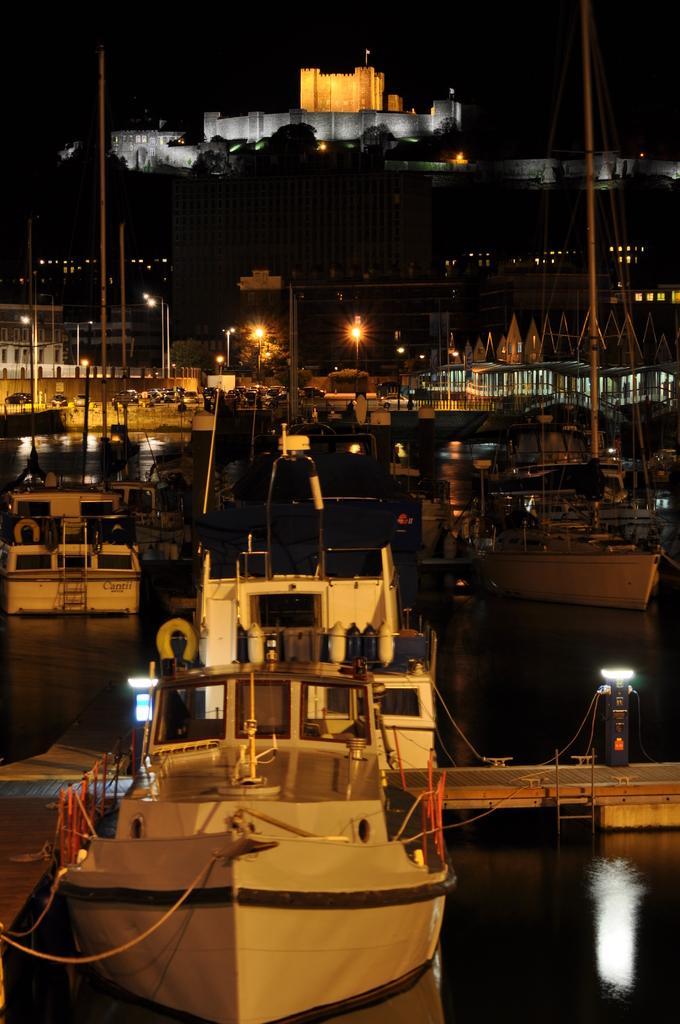Please provide a concise description of this image. Here we can see a ship on the water at the platform and we can also see ropes,poles,light on the ship and other objects and there is a light on a platform. In the background image is dark but we can see ships,poles,metal objects and buildings. 